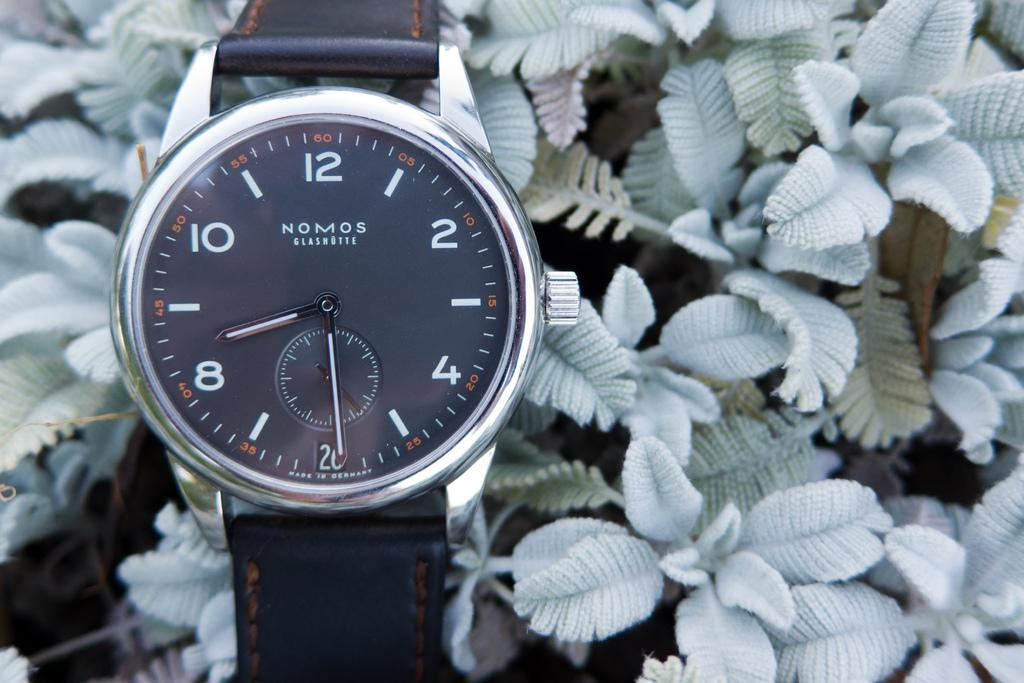<image>
Relay a brief, clear account of the picture shown. A Nomos watch has a black face and a black strap. 